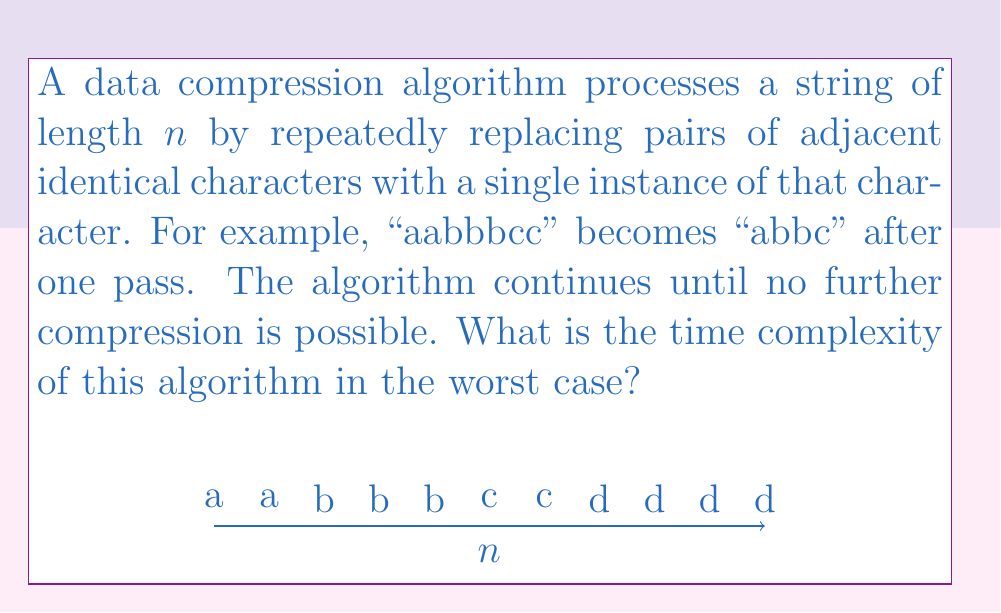Can you answer this question? To analyze the time complexity of this algorithm, let's consider the worst-case scenario:

1. In the worst case, each pass of the algorithm will only compress one pair of characters. This occurs when the string has alternating pairs of identical characters.

2. Let's denote the length of the string after $i$ passes as $n_i$. Initially, $n_0 = n$.

3. After each pass:
   $$n_{i+1} = n_i - 1$$

4. The algorithm terminates when no further compression is possible, which is when the string length becomes $\lceil n/2 \rceil$.

5. The number of passes required, $k$, satisfies:
   $$n - k = \lceil n/2 \rceil$$
   $$k = n - \lceil n/2 \rceil \approx n/2$$

6. Each pass requires scanning the entire string once, which takes $O(n_i)$ time.

7. The total time complexity is the sum of the time taken for each pass:
   $$T(n) = \sum_{i=0}^{k-1} O(n_i) = O(n + (n-1) + (n-2) + ... + (\lceil n/2 \rceil + 1))$$

8. This sum is an arithmetic series with approximately $n/2$ terms, starting at $n$ and ending at $n/2 + 1$.

9. The sum of an arithmetic series is given by $\frac{k(a_1 + a_k)}{2}$, where $k$ is the number of terms, $a_1$ is the first term, and $a_k$ is the last term.

10. Substituting our values:
    $$T(n) = O(\frac{n/2(n + (n/2 + 1))}{2}) = O(\frac{n(3n/2 + 1)}{4}) = O(n^2)$$

Therefore, the worst-case time complexity of this algorithm is quadratic, $O(n^2)$.
Answer: $O(n^2)$ 